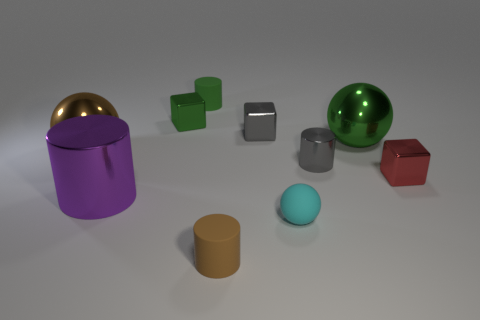What could be the function of the gold-colored dome in the background? The gold-colored dome may serve a decorative purpose in this scene, providing a visual contrast with its reflective surface. It could also be a stylish lid for a container, given its shape and size relative to the other objects. 